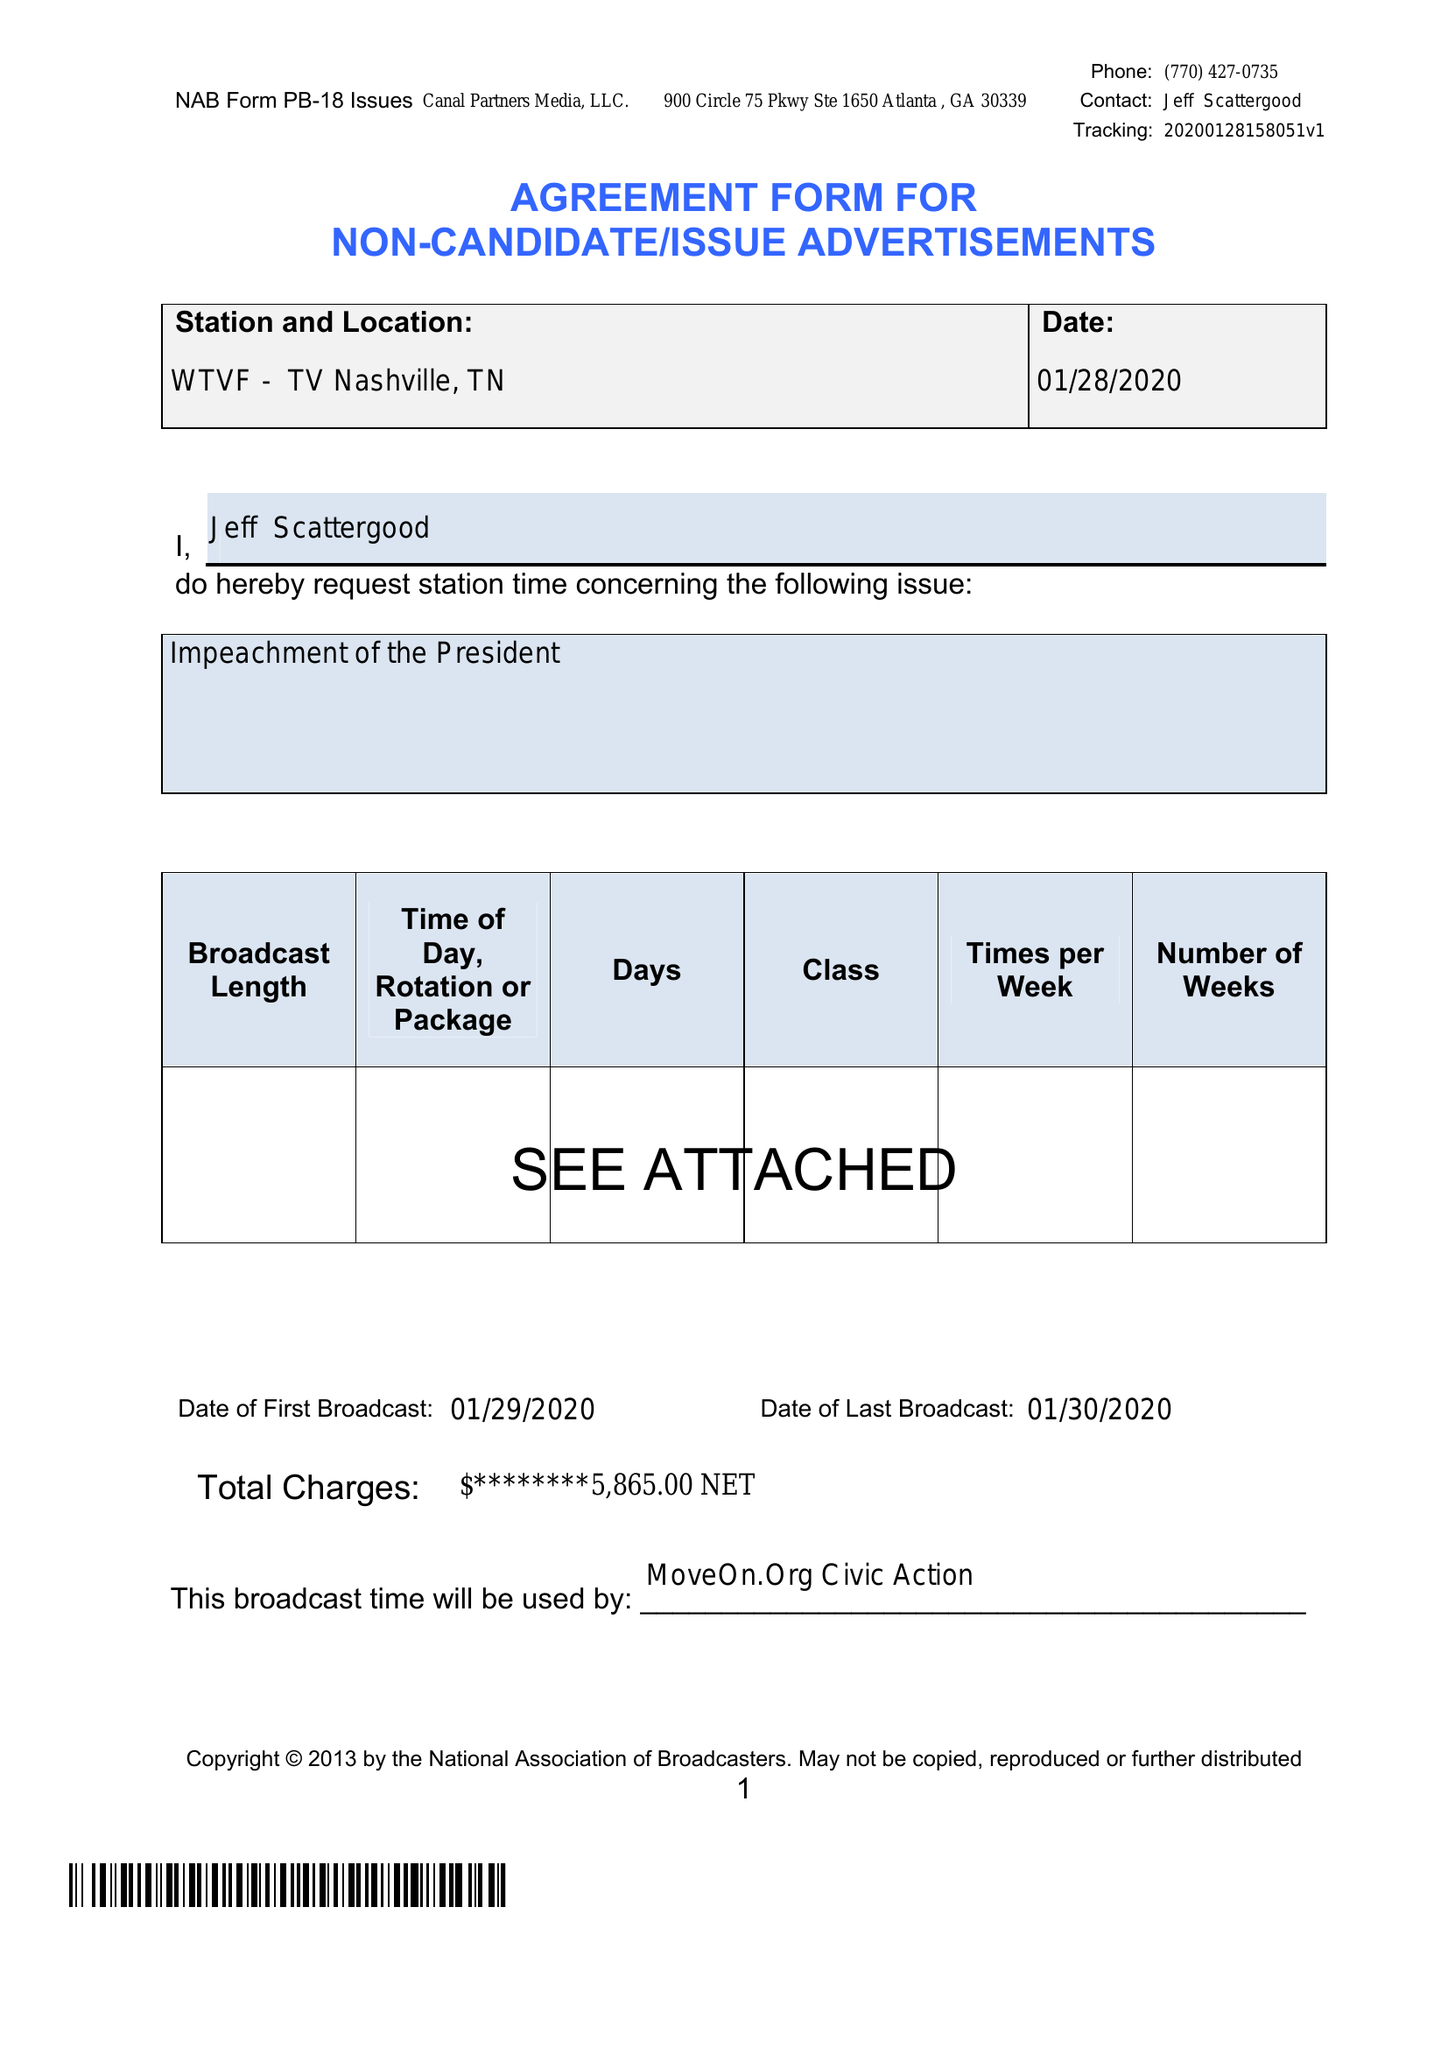What is the value for the advertiser?
Answer the question using a single word or phrase. None 